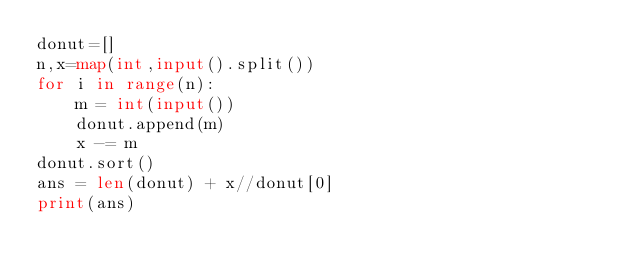<code> <loc_0><loc_0><loc_500><loc_500><_Python_>donut=[]
n,x=map(int,input().split())
for i in range(n):
    m = int(input())
    donut.append(m)
    x -= m
donut.sort()
ans = len(donut) + x//donut[0]
print(ans)</code> 